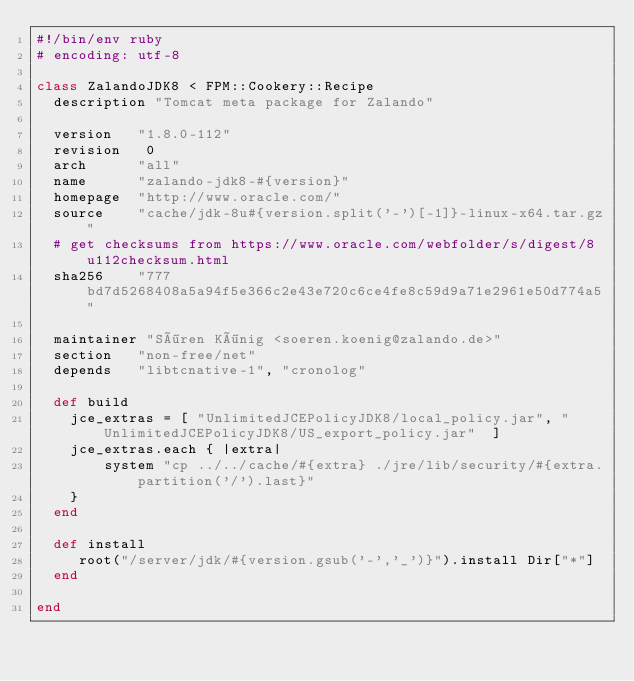<code> <loc_0><loc_0><loc_500><loc_500><_Ruby_>#!/bin/env ruby
# encoding: utf-8

class ZalandoJDK8 < FPM::Cookery::Recipe
  description "Tomcat meta package for Zalando"

  version   "1.8.0-112"
  revision   0
  arch      "all"
  name      "zalando-jdk8-#{version}"
  homepage  "http://www.oracle.com/"
  source    "cache/jdk-8u#{version.split('-')[-1]}-linux-x64.tar.gz"
  # get checksums from https://www.oracle.com/webfolder/s/digest/8u112checksum.html
  sha256    "777bd7d5268408a5a94f5e366c2e43e720c6ce4fe8c59d9a71e2961e50d774a5"

  maintainer "Sören König <soeren.koenig@zalando.de>"
  section   "non-free/net"
  depends   "libtcnative-1", "cronolog"

  def build
    jce_extras = [ "UnlimitedJCEPolicyJDK8/local_policy.jar", "UnlimitedJCEPolicyJDK8/US_export_policy.jar"  ]
    jce_extras.each { |extra|
        system "cp ../../cache/#{extra} ./jre/lib/security/#{extra.partition('/').last}"
    }
  end

  def install
     root("/server/jdk/#{version.gsub('-','_')}").install Dir["*"]
  end

end
</code> 